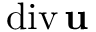Convert formula to latex. <formula><loc_0><loc_0><loc_500><loc_500>d i v \, { u }</formula> 